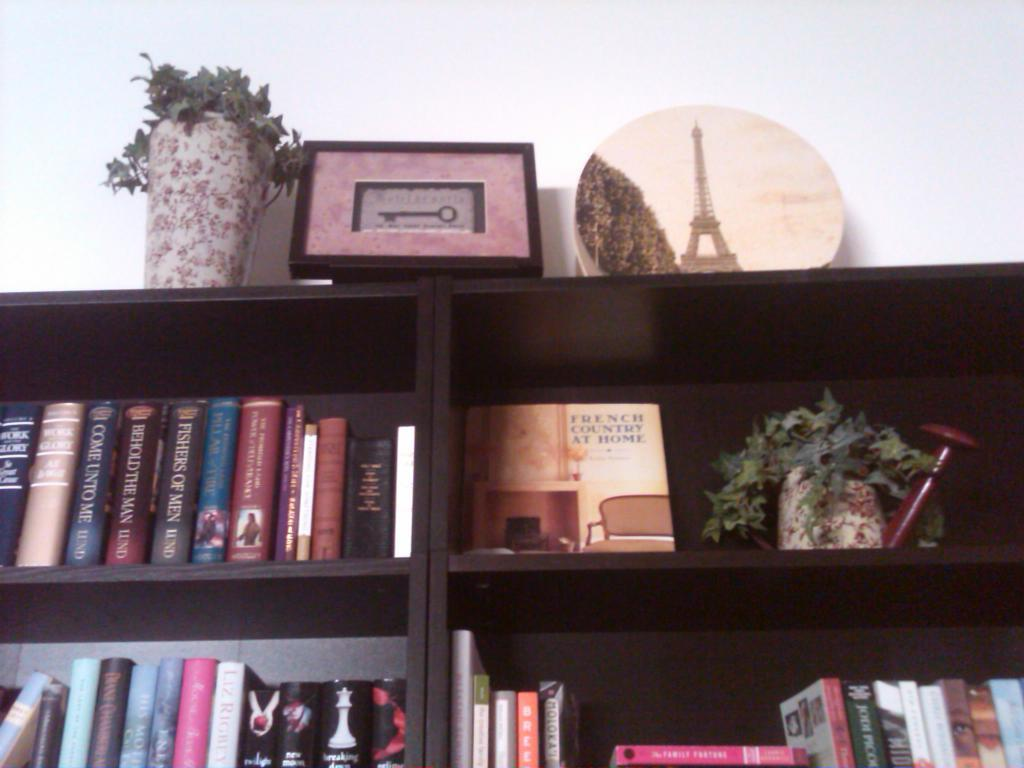<image>
Share a concise interpretation of the image provided. books stacked in a book case include French Country At Home 